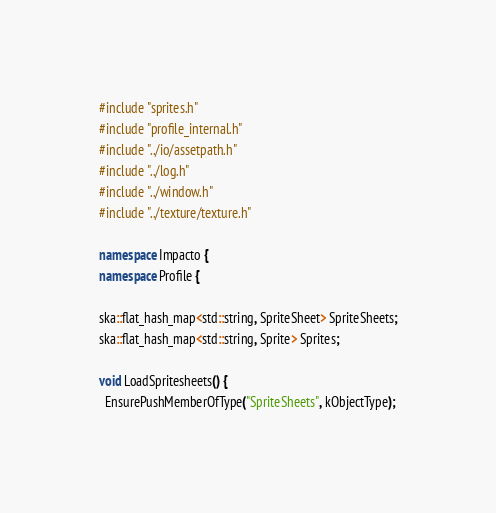<code> <loc_0><loc_0><loc_500><loc_500><_C++_>#include "sprites.h"
#include "profile_internal.h"
#include "../io/assetpath.h"
#include "../log.h"
#include "../window.h"
#include "../texture/texture.h"

namespace Impacto {
namespace Profile {

ska::flat_hash_map<std::string, SpriteSheet> SpriteSheets;
ska::flat_hash_map<std::string, Sprite> Sprites;

void LoadSpritesheets() {
  EnsurePushMemberOfType("SpriteSheets", kObjectType);
</code> 